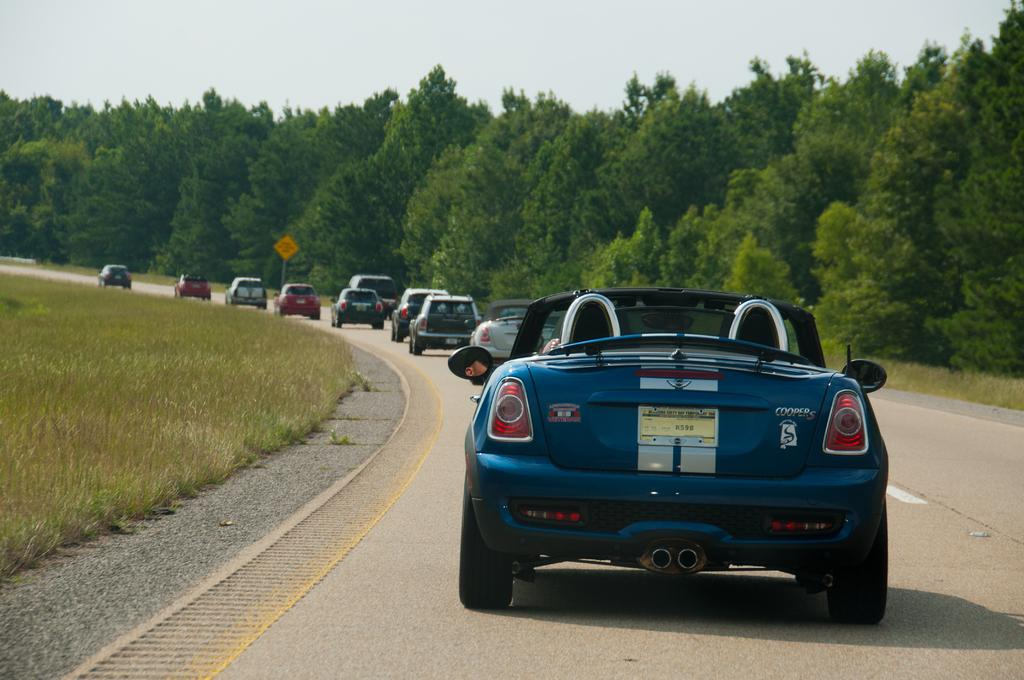What can be seen on the road in the image? There are vehicles on the road in the image. What is visible in the background of the image? There are trees and a signboard in the background of the image. What type of vegetation is present at the bottom left of the image? The ground on the bottom left of the image is covered with grass. What type of texture can be seen on the sheet in the image? There is no sheet present in the image; it features vehicles on the road, trees, a signboard, and grass-covered ground. What type of bun is being served at the event in the image? There is no event or bun depicted in the image. 